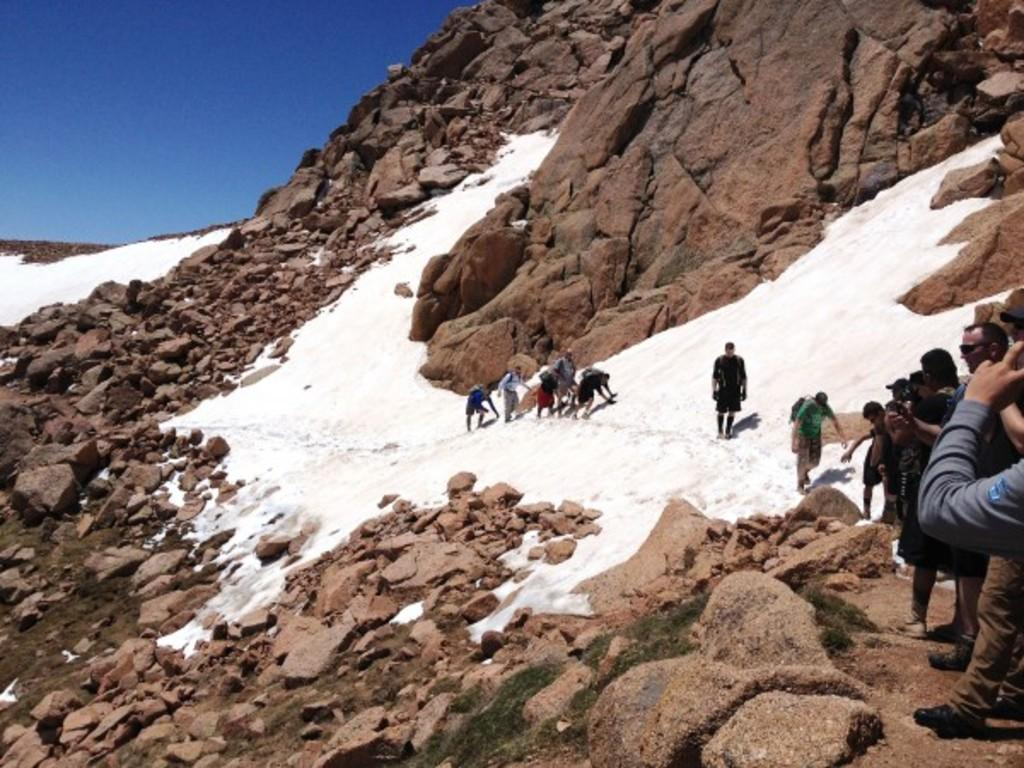Who or what is present in the image? There are people in the image. What are the people doing in the image? The people are standing and walking on the snow. What are the people holding in the image? The people are holding cameras. What other objects or features can be seen in the image? There are rocks in the image. What can be seen in the background of the image? The sky is visible in the image. Where is the match being lit in the image? There is no match present in the image. What event is being celebrated in the image? The image does not depict a specific event or celebration. 